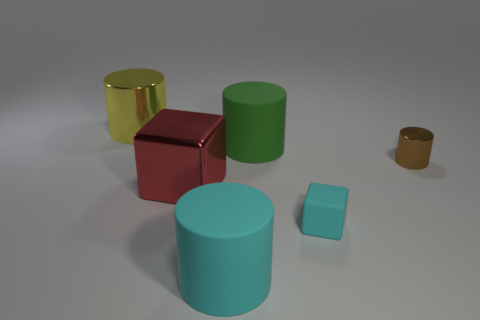There is a big object that is the same color as the matte cube; what shape is it?
Provide a short and direct response. Cylinder. There is a large metallic object in front of the large yellow cylinder; is it the same shape as the brown thing?
Your answer should be compact. No. There is a cylinder that is the same size as the matte block; what is its color?
Give a very brief answer. Brown. How many tiny balls are there?
Give a very brief answer. 0. Do the cylinder in front of the tiny cylinder and the tiny cyan thing have the same material?
Your answer should be compact. Yes. There is a thing that is left of the big cyan object and behind the red shiny block; what material is it made of?
Your answer should be very brief. Metal. What material is the cylinder that is right of the block to the right of the big cyan cylinder?
Offer a terse response. Metal. There is a cylinder on the right side of the large matte cylinder that is behind the large matte cylinder in front of the brown object; how big is it?
Make the answer very short. Small. How many objects are made of the same material as the large red cube?
Provide a succinct answer. 2. There is a metallic cylinder in front of the big metallic thing that is behind the brown shiny cylinder; what color is it?
Provide a short and direct response. Brown. 